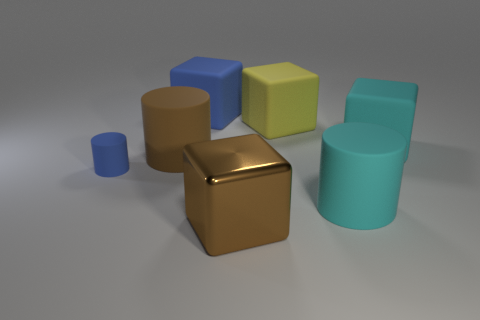Add 2 large rubber cylinders. How many objects exist? 9 Subtract all blocks. How many objects are left? 3 Add 1 large metal spheres. How many large metal spheres exist? 1 Subtract 0 red balls. How many objects are left? 7 Subtract all brown objects. Subtract all small blue objects. How many objects are left? 4 Add 5 cyan rubber cylinders. How many cyan rubber cylinders are left? 6 